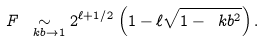Convert formula to latex. <formula><loc_0><loc_0><loc_500><loc_500>F \underset { \ k b \rightarrow 1 } { \sim } 2 ^ { \ell + 1 / 2 } \left ( 1 - \ell \sqrt { 1 - \ k b ^ { 2 } } \right ) .</formula> 